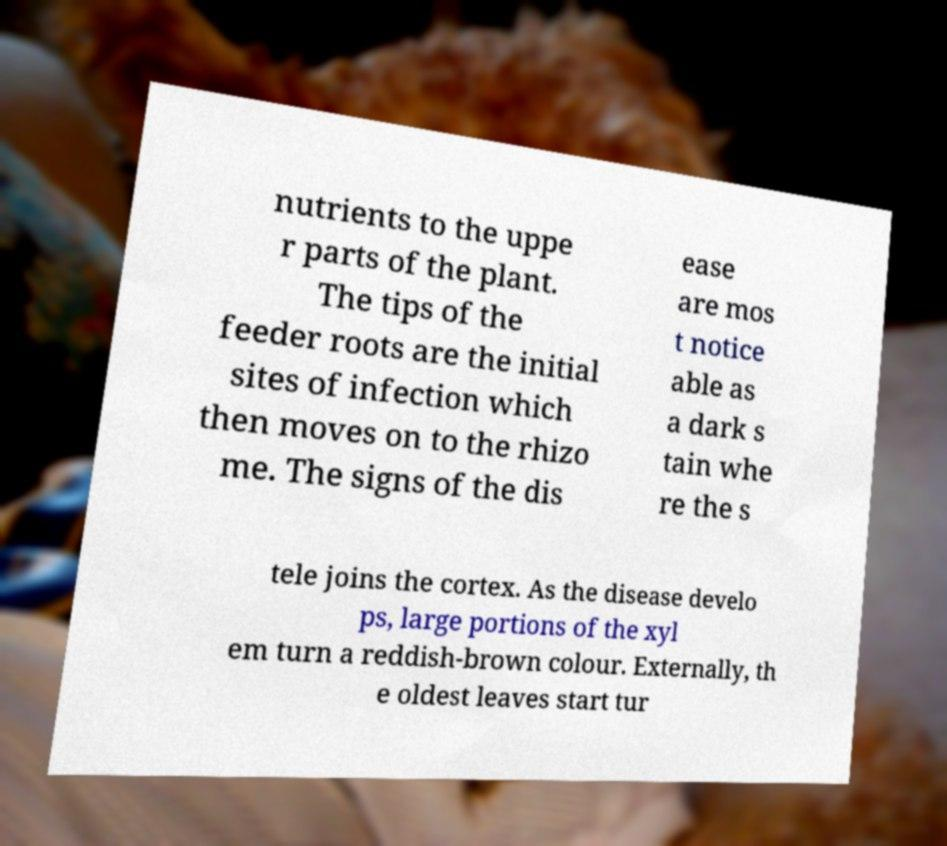Can you read and provide the text displayed in the image?This photo seems to have some interesting text. Can you extract and type it out for me? nutrients to the uppe r parts of the plant. The tips of the feeder roots are the initial sites of infection which then moves on to the rhizo me. The signs of the dis ease are mos t notice able as a dark s tain whe re the s tele joins the cortex. As the disease develo ps, large portions of the xyl em turn a reddish-brown colour. Externally, th e oldest leaves start tur 